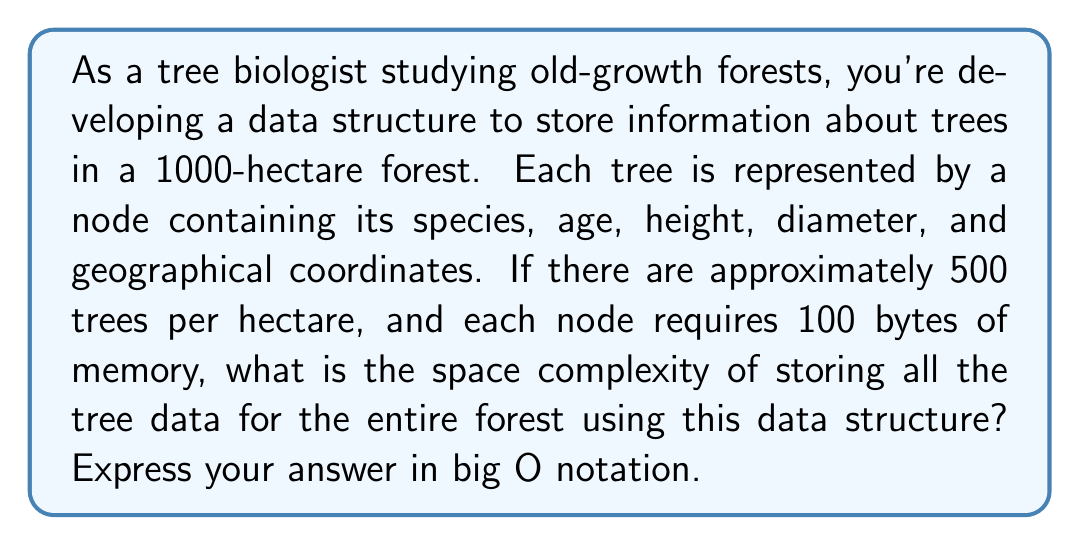Provide a solution to this math problem. To solve this problem, let's break it down step by step:

1. Calculate the total number of trees:
   - Forest area = 1000 hectares
   - Trees per hectare ≈ 500
   - Total number of trees = 1000 * 500 = 500,000 trees

2. Calculate the total memory required:
   - Each node (tree) requires 100 bytes
   - Total memory = 500,000 * 100 bytes = 50,000,000 bytes

3. Analyze the space complexity:
   - The space required grows linearly with the number of trees
   - Let $n$ be the number of trees
   - The space required is directly proportional to $n$

4. Express in big O notation:
   - Since the space grows linearly with $n$, the space complexity is $O(n)$

In this case, the constant factors (100 bytes per node) and the fixed forest size (1000 hectares) don't affect the big O notation. We're interested in how the space requirements scale with the input size (number of trees), which is linear.

It's worth noting that while the actual memory used is 50 MB, in big O notation we're concerned with the growth rate, not the exact value. Therefore, regardless of whether we're storing 500,000 trees or 1,000,000 trees, the space complexity remains $O(n)$.
Answer: $O(n)$, where $n$ is the number of trees in the forest. 